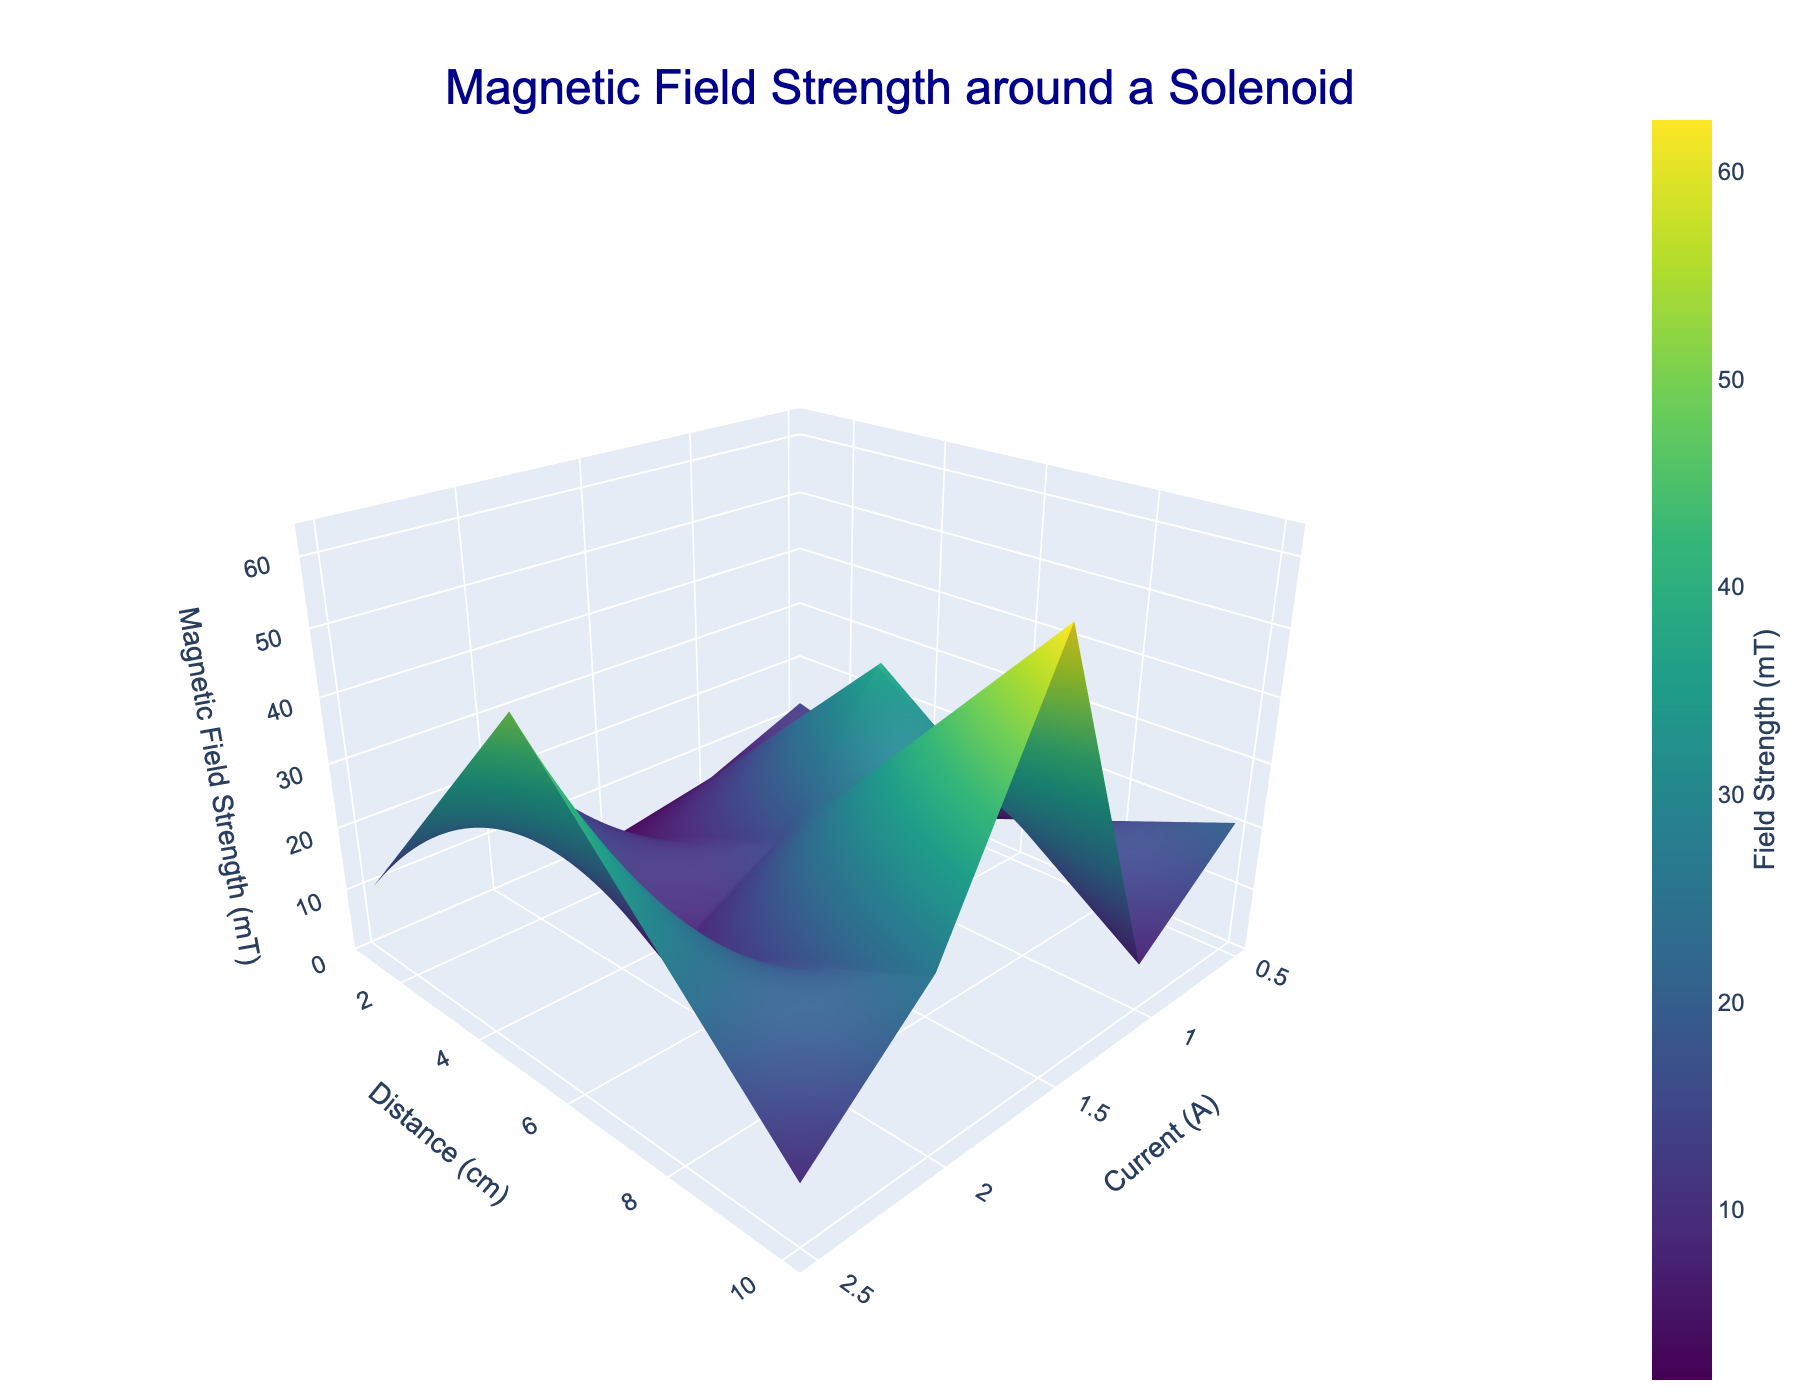What is the title of the plot? The title of the plot is provided at the top of the figure. It states what the plot represents.
Answer: Magnetic Field Strength around a Solenoid What do the axes of the 3D plot represent? The axes are labeled with different physical quantities. The x-axis represents 'Current (A)', the y-axis represents 'Distance (cm)', and the z-axis represents 'Magnetic Field Strength (mT)'.
Answer: Current (A), Distance (cm), Magnetic Field Strength (mT) Which color represents the highest magnetic field strength in the plot? The highest magnetic field strength is indicated by the brightest color on the color scale used in the figure. In Viridis color scale, this is typically bright yellow.
Answer: Bright yellow How does the magnetic field strength change as the current increases at a fixed distance of 5 cm? As the current increases from 0.5 A to 2.5 A at a fixed distance of 5 cm, the magnetic field strength increases proportionally from 5.2 mT to 26.0 mT.
Answer: It increases Compare the magnetic field strengths at 1 cm and 10 cm distances for a current of 1.5 A. The magnetic field strength at 1 cm is higher compared to 10 cm for 1.5 A current. Specifically, it is 37.5 mT at 1 cm and 5.4 mT at 10 cm.
Answer: 37.5 mT vs 5.4 mT How does the distance from the solenoid affect the magnetic field strength at a fixed current? At a fixed current, as the distance increases, the magnetic field strength decreases. This is observed for any current value in the plot.
Answer: It decreases What is the difference in magnetic field strength between 2.0 A at 1 cm and 2.5 A at 5 cm? Looking at the z-axis values, 2.0 A at 1 cm shows 50.0 mT and 2.5 A at 5 cm shows 26.0 mT. The difference is 50.0 - 26.0.
Answer: 24.0 mT If the distance is kept constant at 10 cm, what is the average magnetic field strength for all currents? Summing the magnetic field strengths at 10 cm for all currents (1.8 + 3.6 + 5.4 + 7.2 + 9.0) and then dividing by the number of data points (5), we get the average.  sum = 27.0, average = 27.0 / 5.
Answer: 5.4 mT Which combination of current and distance yields the lowest magnetic field strength? Check all combinations in the 3D plot. The lowest field strength occurs at 0.5 A and 10 cm, which is 1.8 mT.
Answer: 0.5 A, 10 cm Which current value shows the most significant increase in magnetic field strength between 5 cm and 10 cm distances? By comparing the differences in magnetic field strengths for each current between 5 cm and 10 cm, the largest increase occurs at the lowest current, 0.5 A: 5.2 - 1.8 = 3.4 mT.
Answer: 0.5 A 